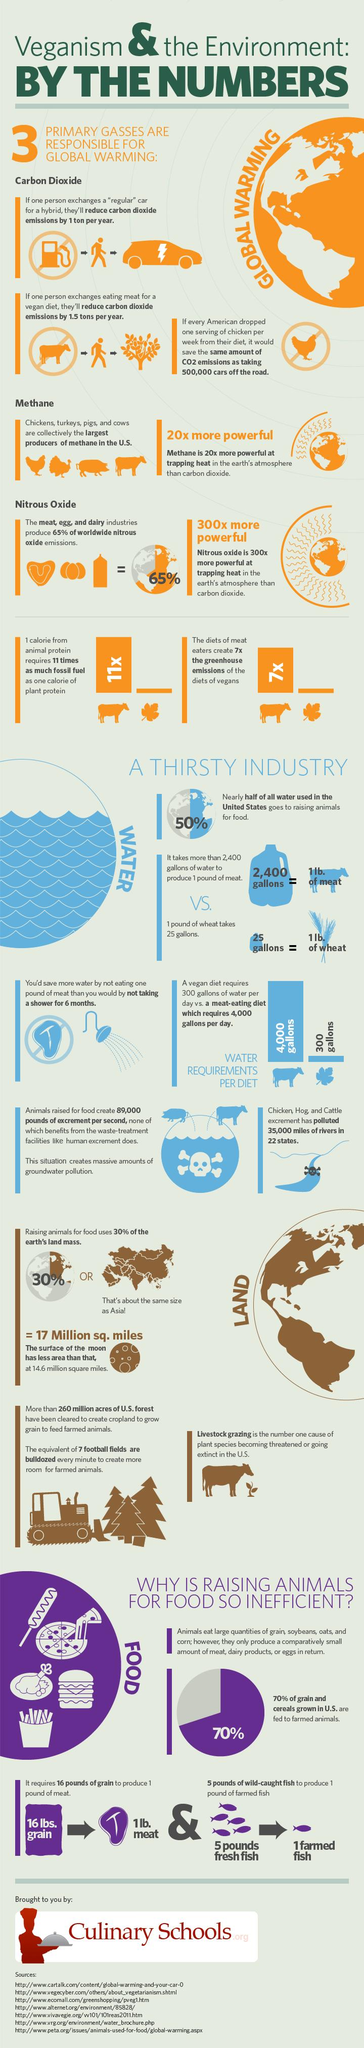Highlight a few significant elements in this photo. I'm not sure what you are asking. Could you please clarify or provide more context? Carbon dioxide, methane, and nitrous oxide are the gases primarily responsible for global warming. On average, meat eaters require significantly more water per day than vegan dieters, at 3,700 gallons compared to 2,400 gallons, respectively. 